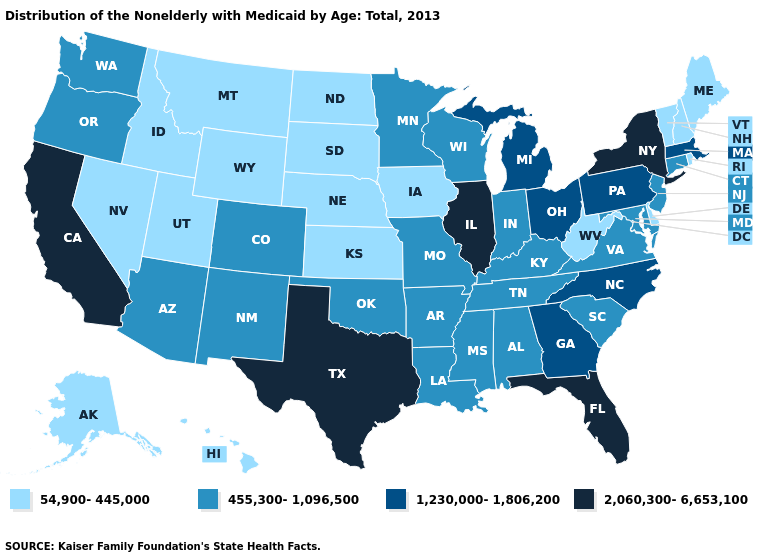Does South Dakota have the lowest value in the USA?
Be succinct. Yes. Is the legend a continuous bar?
Answer briefly. No. Is the legend a continuous bar?
Concise answer only. No. Which states have the lowest value in the South?
Quick response, please. Delaware, West Virginia. Name the states that have a value in the range 455,300-1,096,500?
Keep it brief. Alabama, Arizona, Arkansas, Colorado, Connecticut, Indiana, Kentucky, Louisiana, Maryland, Minnesota, Mississippi, Missouri, New Jersey, New Mexico, Oklahoma, Oregon, South Carolina, Tennessee, Virginia, Washington, Wisconsin. Name the states that have a value in the range 54,900-445,000?
Be succinct. Alaska, Delaware, Hawaii, Idaho, Iowa, Kansas, Maine, Montana, Nebraska, Nevada, New Hampshire, North Dakota, Rhode Island, South Dakota, Utah, Vermont, West Virginia, Wyoming. What is the lowest value in states that border New Hampshire?
Quick response, please. 54,900-445,000. What is the value of Colorado?
Short answer required. 455,300-1,096,500. Name the states that have a value in the range 455,300-1,096,500?
Keep it brief. Alabama, Arizona, Arkansas, Colorado, Connecticut, Indiana, Kentucky, Louisiana, Maryland, Minnesota, Mississippi, Missouri, New Jersey, New Mexico, Oklahoma, Oregon, South Carolina, Tennessee, Virginia, Washington, Wisconsin. Name the states that have a value in the range 54,900-445,000?
Give a very brief answer. Alaska, Delaware, Hawaii, Idaho, Iowa, Kansas, Maine, Montana, Nebraska, Nevada, New Hampshire, North Dakota, Rhode Island, South Dakota, Utah, Vermont, West Virginia, Wyoming. What is the lowest value in the South?
Concise answer only. 54,900-445,000. Does New York have the highest value in the Northeast?
Concise answer only. Yes. Name the states that have a value in the range 1,230,000-1,806,200?
Quick response, please. Georgia, Massachusetts, Michigan, North Carolina, Ohio, Pennsylvania. Name the states that have a value in the range 455,300-1,096,500?
Quick response, please. Alabama, Arizona, Arkansas, Colorado, Connecticut, Indiana, Kentucky, Louisiana, Maryland, Minnesota, Mississippi, Missouri, New Jersey, New Mexico, Oklahoma, Oregon, South Carolina, Tennessee, Virginia, Washington, Wisconsin. 